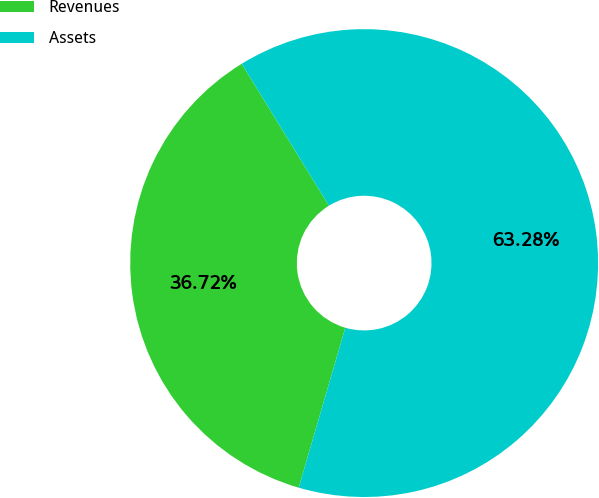<chart> <loc_0><loc_0><loc_500><loc_500><pie_chart><fcel>Revenues<fcel>Assets<nl><fcel>36.72%<fcel>63.28%<nl></chart> 